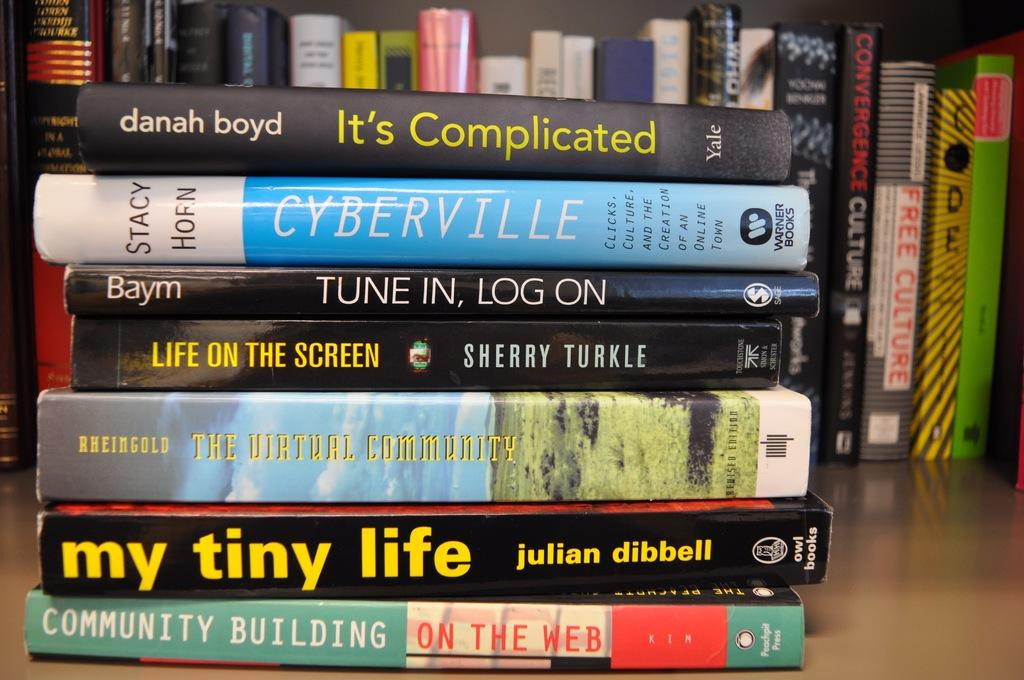<image>
Provide a brief description of the given image. Books stacked on top of one another with one that says "Life on the Screen" in the middle. 